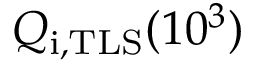<formula> <loc_0><loc_0><loc_500><loc_500>Q _ { i , T L S } ( 1 0 ^ { 3 } )</formula> 